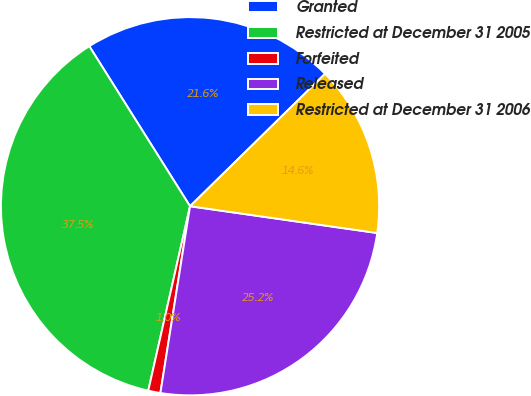Convert chart to OTSL. <chart><loc_0><loc_0><loc_500><loc_500><pie_chart><fcel>Granted<fcel>Restricted at December 31 2005<fcel>Forfeited<fcel>Released<fcel>Restricted at December 31 2006<nl><fcel>21.59%<fcel>37.51%<fcel>1.04%<fcel>25.24%<fcel>14.61%<nl></chart> 